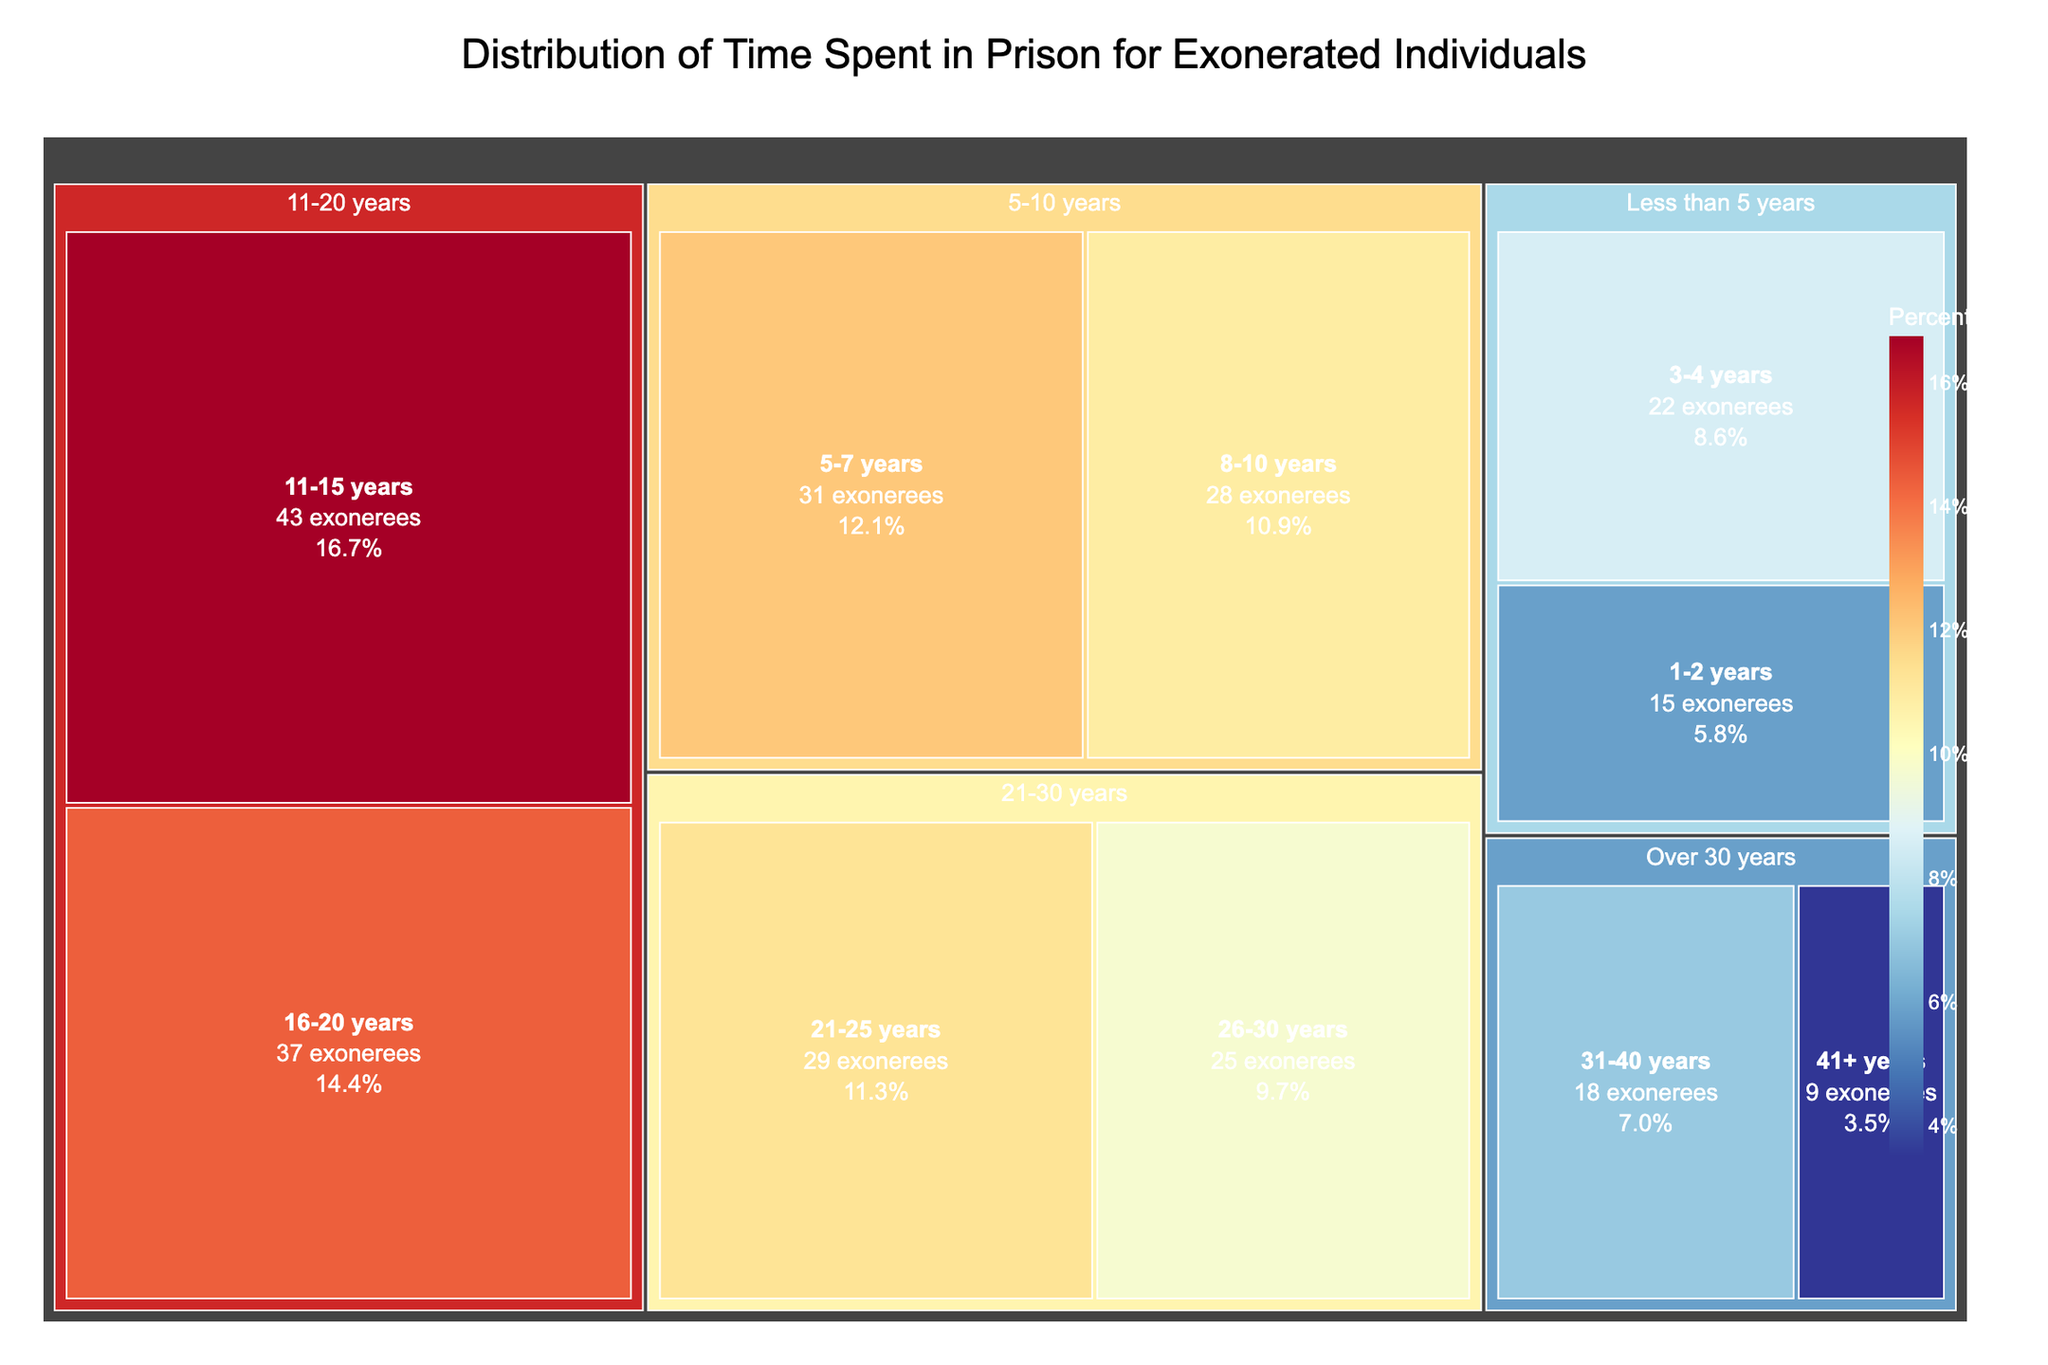How many exonerees spent between 1-2 years in prison? The figure mentions that in the "Less than 5 years" category, there are 15 exonerees who spent between 1-2 years in prison.
Answer: 15 Which category has the highest number of exonerees? By observing the treemap, the "11-20 years" category (containing the subcategories "11-15 years" and "16-20 years") has the highest number of exonerees, with 43 and 37 exonerees, respectively. The total is 80.
Answer: 11-20 years How many exonerees spent over 30 years in prison? The figure shows two subcategories in the "Over 30 years" category: "31-40 years" with 18 exonerees and "41+ years" with 9 exonerees. Adding these together gives 27 exonerees.
Answer: 27 What is the percentage of exonerees who spent 21-25 years in prison? The figure provides the percentage directly in the label for the "21-25 years" category. Since specific percentages are calculated based on the data, we can find it in the visual representation.
Answer: Specific percentage from the figure Compare the number of exonerees who spent 8-10 years in prison to those who spent 41+ years. Which is higher? The figure shows 28 exonerees in the "8-10 years" and 9 exonerees in the "41+ years" category. 28 is greater than 9.
Answer: 8-10 years What is the combined total of exonerees who spent 8-10 years and 11-15 years in prison? Summing 28 exonerees from the "8-10 years" category and 43 exonerees from the "11-15 years" category yields 71 exonerees.
Answer: 71 Which spends more: Exonerees with 5-7 years or those with 31-40 years in prison? The treemap shows 31 exonerees in the "5-7 years" category and 18 exonerees in the "31-40 years" category. 31 is greater than 18.
Answer: 5-7 years What is the average number of exonerees for the subcategories within 11-20 years? Averaging the "11-15 years" (43) and "16-20 years" (37) categories results in (43 + 37) / 2 = 40.
Answer: 40 